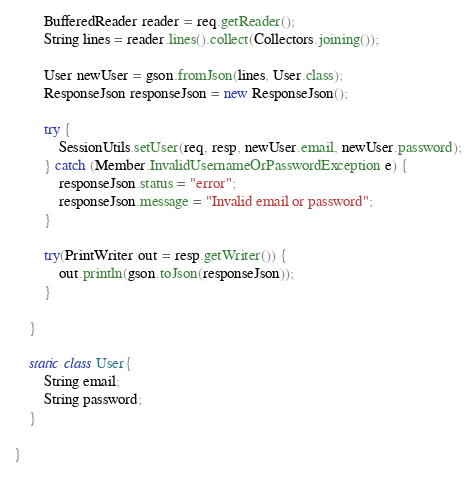Convert code to text. <code><loc_0><loc_0><loc_500><loc_500><_Java_>        BufferedReader reader = req.getReader();
        String lines = reader.lines().collect(Collectors.joining());

        User newUser = gson.fromJson(lines, User.class);
        ResponseJson responseJson = new ResponseJson();

        try {
            SessionUtils.setUser(req, resp, newUser.email, newUser.password);
        } catch (Member.InvalidUsernameOrPasswordException e) {
            responseJson.status = "error";
            responseJson.message = "Invalid email or password";
        }

        try(PrintWriter out = resp.getWriter()) {
            out.println(gson.toJson(responseJson));
        }

    }

    static class User{
        String email;
        String password;
    }

}
</code> 